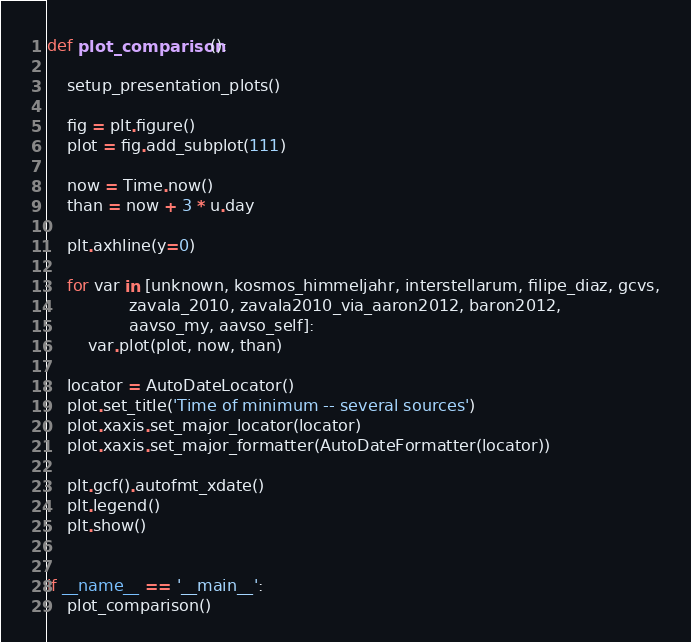<code> <loc_0><loc_0><loc_500><loc_500><_Python_>def plot_comparison():

    setup_presentation_plots()

    fig = plt.figure()
    plot = fig.add_subplot(111)

    now = Time.now()
    than = now + 3 * u.day

    plt.axhline(y=0)

    for var in [unknown, kosmos_himmeljahr, interstellarum, filipe_diaz, gcvs,
                zavala_2010, zavala2010_via_aaron2012, baron2012,
                aavso_my, aavso_self]:
        var.plot(plot, now, than)

    locator = AutoDateLocator()
    plot.set_title('Time of minimum -- several sources')
    plot.xaxis.set_major_locator(locator)
    plot.xaxis.set_major_formatter(AutoDateFormatter(locator))

    plt.gcf().autofmt_xdate()
    plt.legend()
    plt.show()


if __name__ == '__main__':
    plot_comparison()
</code> 